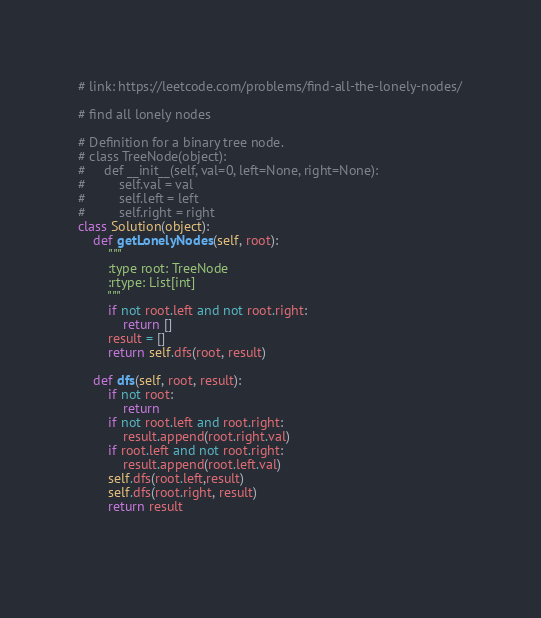<code> <loc_0><loc_0><loc_500><loc_500><_Python_># link: https://leetcode.com/problems/find-all-the-lonely-nodes/

# find all lonely nodes

# Definition for a binary tree node.
# class TreeNode(object):
#     def __init__(self, val=0, left=None, right=None):
#         self.val = val
#         self.left = left
#         self.right = right
class Solution(object):
    def getLonelyNodes(self, root):
        """
        :type root: TreeNode
        :rtype: List[int]
        """
        if not root.left and not root.right:
            return []
        result = []
        return self.dfs(root, result)
        
    def dfs(self, root, result):
        if not root:
            return
        if not root.left and root.right:
            result.append(root.right.val)
        if root.left and not root.right:
            result.append(root.left.val)
        self.dfs(root.left,result)
        self.dfs(root.right, result)
        return result
        
        </code> 